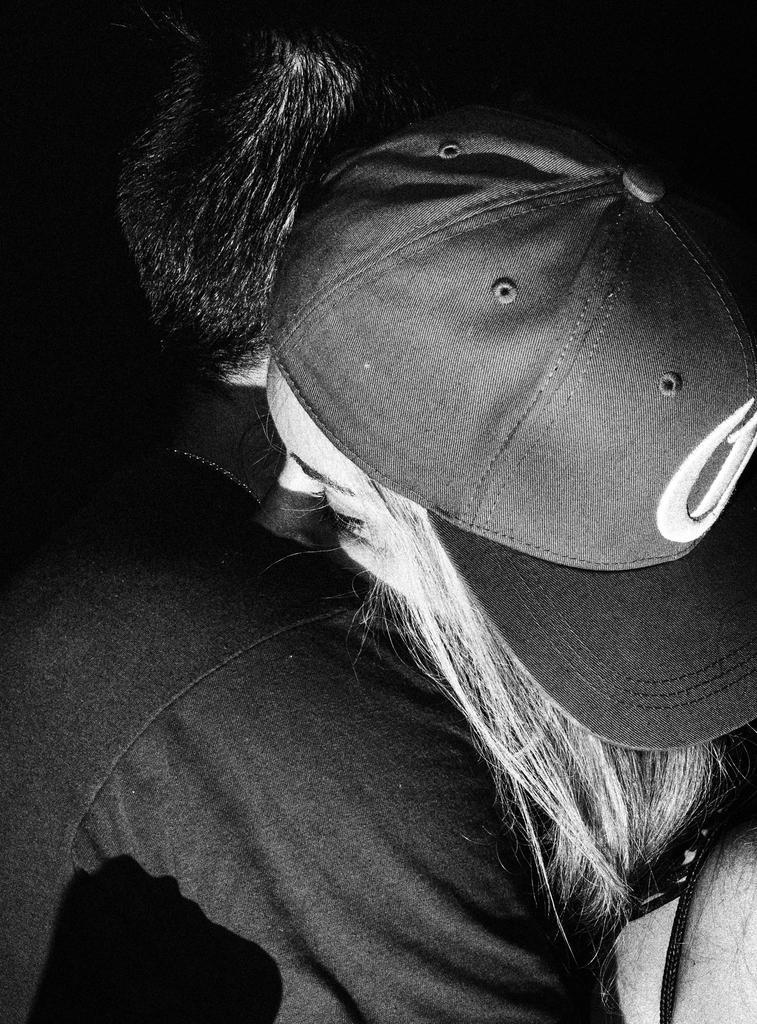How would you summarize this image in a sentence or two? In this image I can see the two people with dresses and one person with the cap. And this is a black and white image. 